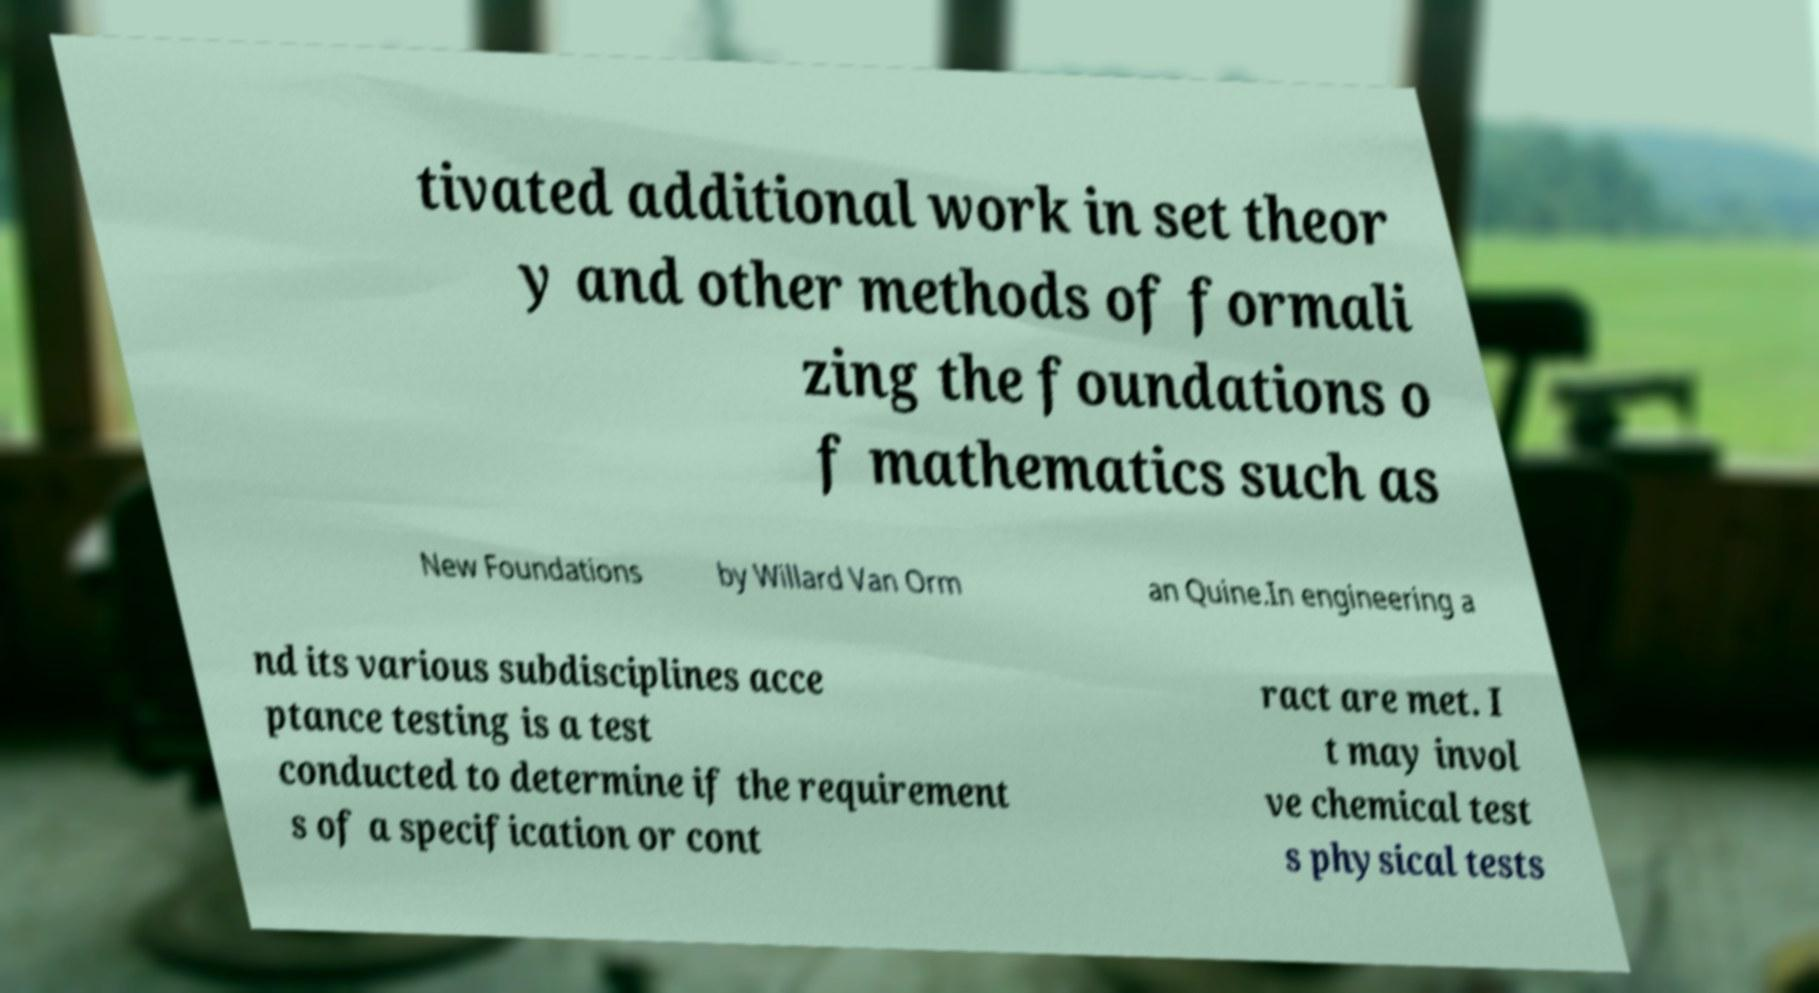Can you read and provide the text displayed in the image?This photo seems to have some interesting text. Can you extract and type it out for me? tivated additional work in set theor y and other methods of formali zing the foundations o f mathematics such as New Foundations by Willard Van Orm an Quine.In engineering a nd its various subdisciplines acce ptance testing is a test conducted to determine if the requirement s of a specification or cont ract are met. I t may invol ve chemical test s physical tests 